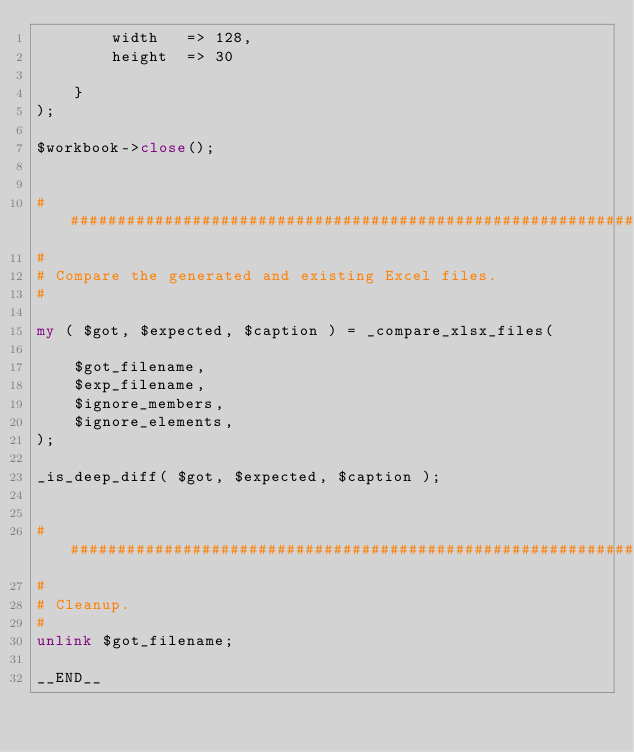<code> <loc_0><loc_0><loc_500><loc_500><_Perl_>        width   => 128,
        height  => 30

    }
);

$workbook->close();


###############################################################################
#
# Compare the generated and existing Excel files.
#

my ( $got, $expected, $caption ) = _compare_xlsx_files(

    $got_filename,
    $exp_filename,
    $ignore_members,
    $ignore_elements,
);

_is_deep_diff( $got, $expected, $caption );


###############################################################################
#
# Cleanup.
#
unlink $got_filename;

__END__



</code> 